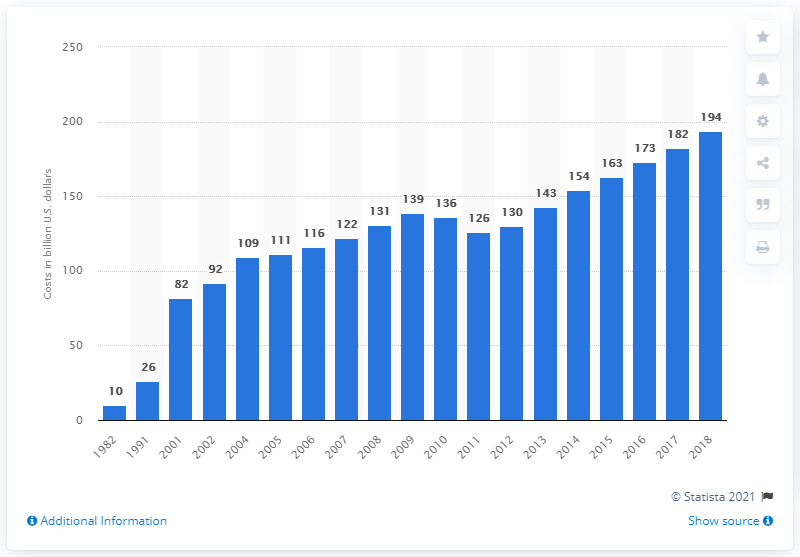Point out several critical features in this image. The amount of costs for research and development in health care in 2018 was $194 million. The expenditures for research and development in the health care sector from 1982 to 2018 totaled 139 billion U.S. dollars. 